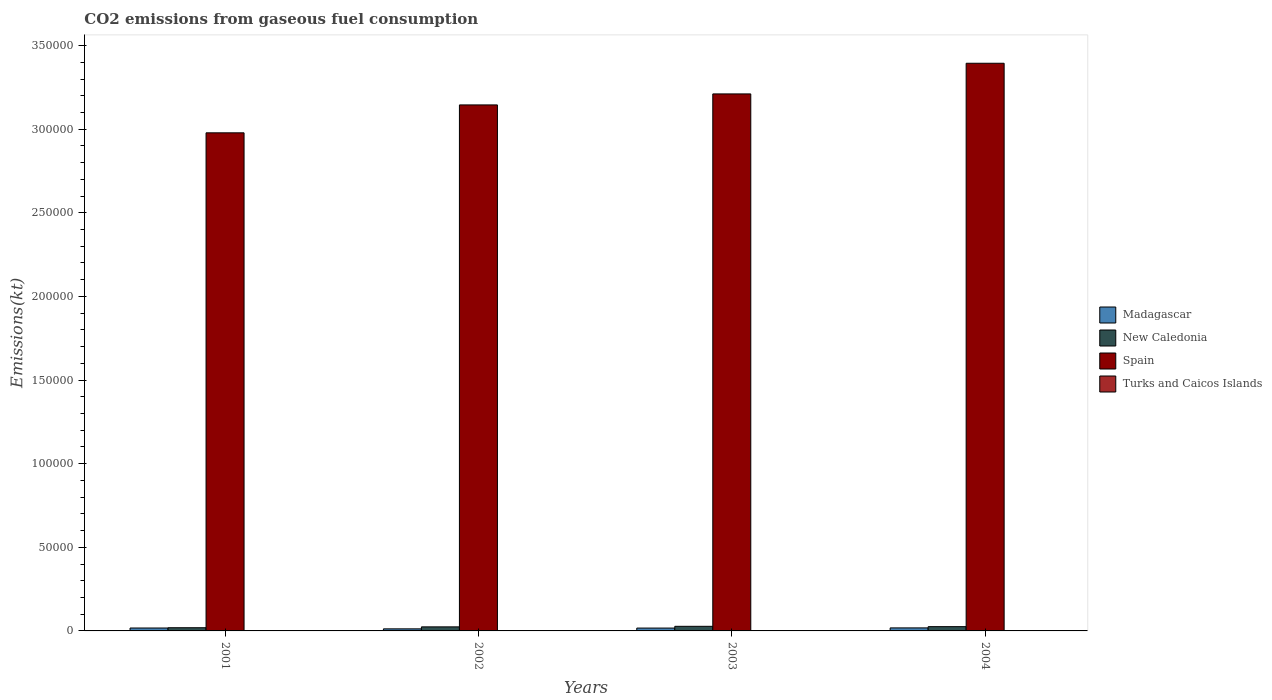How many different coloured bars are there?
Provide a succinct answer. 4. How many groups of bars are there?
Make the answer very short. 4. Are the number of bars per tick equal to the number of legend labels?
Give a very brief answer. Yes. How many bars are there on the 4th tick from the left?
Give a very brief answer. 4. In how many cases, is the number of bars for a given year not equal to the number of legend labels?
Your answer should be very brief. 0. What is the amount of CO2 emitted in Turks and Caicos Islands in 2004?
Your response must be concise. 102.68. Across all years, what is the maximum amount of CO2 emitted in Madagascar?
Offer a very short reply. 1807.83. Across all years, what is the minimum amount of CO2 emitted in Madagascar?
Give a very brief answer. 1235.78. In which year was the amount of CO2 emitted in New Caledonia maximum?
Make the answer very short. 2003. What is the total amount of CO2 emitted in Spain in the graph?
Give a very brief answer. 1.27e+06. What is the difference between the amount of CO2 emitted in Turks and Caicos Islands in 2001 and that in 2004?
Ensure brevity in your answer.  -88.01. What is the difference between the amount of CO2 emitted in New Caledonia in 2001 and the amount of CO2 emitted in Madagascar in 2004?
Keep it short and to the point. 99.01. What is the average amount of CO2 emitted in New Caledonia per year?
Make the answer very short. 2409.22. In the year 2003, what is the difference between the amount of CO2 emitted in New Caledonia and amount of CO2 emitted in Turks and Caicos Islands?
Offer a very short reply. 2647.57. What is the ratio of the amount of CO2 emitted in Madagascar in 2001 to that in 2003?
Keep it short and to the point. 1.02. What is the difference between the highest and the second highest amount of CO2 emitted in Madagascar?
Offer a terse response. 66.01. What is the difference between the highest and the lowest amount of CO2 emitted in Spain?
Provide a succinct answer. 4.16e+04. Is it the case that in every year, the sum of the amount of CO2 emitted in Madagascar and amount of CO2 emitted in Turks and Caicos Islands is greater than the sum of amount of CO2 emitted in Spain and amount of CO2 emitted in New Caledonia?
Offer a terse response. Yes. What does the 4th bar from the left in 2002 represents?
Provide a short and direct response. Turks and Caicos Islands. What does the 2nd bar from the right in 2003 represents?
Provide a short and direct response. Spain. Is it the case that in every year, the sum of the amount of CO2 emitted in New Caledonia and amount of CO2 emitted in Madagascar is greater than the amount of CO2 emitted in Spain?
Offer a very short reply. No. How many years are there in the graph?
Offer a terse response. 4. Does the graph contain grids?
Provide a short and direct response. No. Where does the legend appear in the graph?
Your answer should be compact. Center right. How are the legend labels stacked?
Your response must be concise. Vertical. What is the title of the graph?
Provide a short and direct response. CO2 emissions from gaseous fuel consumption. What is the label or title of the Y-axis?
Offer a very short reply. Emissions(kt). What is the Emissions(kt) in Madagascar in 2001?
Your answer should be compact. 1741.83. What is the Emissions(kt) of New Caledonia in 2001?
Make the answer very short. 1906.84. What is the Emissions(kt) in Spain in 2001?
Ensure brevity in your answer.  2.98e+05. What is the Emissions(kt) of Turks and Caicos Islands in 2001?
Make the answer very short. 14.67. What is the Emissions(kt) in Madagascar in 2002?
Make the answer very short. 1235.78. What is the Emissions(kt) in New Caledonia in 2002?
Give a very brief answer. 2427.55. What is the Emissions(kt) of Spain in 2002?
Your answer should be compact. 3.15e+05. What is the Emissions(kt) in Turks and Caicos Islands in 2002?
Your answer should be compact. 99.01. What is the Emissions(kt) of Madagascar in 2003?
Offer a terse response. 1701.49. What is the Emissions(kt) of New Caledonia in 2003?
Your answer should be compact. 2750.25. What is the Emissions(kt) in Spain in 2003?
Your answer should be very brief. 3.21e+05. What is the Emissions(kt) of Turks and Caicos Islands in 2003?
Your response must be concise. 102.68. What is the Emissions(kt) in Madagascar in 2004?
Offer a very short reply. 1807.83. What is the Emissions(kt) in New Caledonia in 2004?
Offer a terse response. 2552.23. What is the Emissions(kt) of Spain in 2004?
Make the answer very short. 3.39e+05. What is the Emissions(kt) in Turks and Caicos Islands in 2004?
Ensure brevity in your answer.  102.68. Across all years, what is the maximum Emissions(kt) in Madagascar?
Make the answer very short. 1807.83. Across all years, what is the maximum Emissions(kt) in New Caledonia?
Ensure brevity in your answer.  2750.25. Across all years, what is the maximum Emissions(kt) in Spain?
Your answer should be very brief. 3.39e+05. Across all years, what is the maximum Emissions(kt) of Turks and Caicos Islands?
Offer a very short reply. 102.68. Across all years, what is the minimum Emissions(kt) of Madagascar?
Give a very brief answer. 1235.78. Across all years, what is the minimum Emissions(kt) of New Caledonia?
Keep it short and to the point. 1906.84. Across all years, what is the minimum Emissions(kt) in Spain?
Give a very brief answer. 2.98e+05. Across all years, what is the minimum Emissions(kt) in Turks and Caicos Islands?
Your response must be concise. 14.67. What is the total Emissions(kt) of Madagascar in the graph?
Ensure brevity in your answer.  6486.92. What is the total Emissions(kt) in New Caledonia in the graph?
Make the answer very short. 9636.88. What is the total Emissions(kt) in Spain in the graph?
Provide a succinct answer. 1.27e+06. What is the total Emissions(kt) in Turks and Caicos Islands in the graph?
Your answer should be compact. 319.03. What is the difference between the Emissions(kt) in Madagascar in 2001 and that in 2002?
Provide a succinct answer. 506.05. What is the difference between the Emissions(kt) in New Caledonia in 2001 and that in 2002?
Offer a very short reply. -520.71. What is the difference between the Emissions(kt) in Spain in 2001 and that in 2002?
Keep it short and to the point. -1.67e+04. What is the difference between the Emissions(kt) in Turks and Caicos Islands in 2001 and that in 2002?
Give a very brief answer. -84.34. What is the difference between the Emissions(kt) in Madagascar in 2001 and that in 2003?
Give a very brief answer. 40.34. What is the difference between the Emissions(kt) in New Caledonia in 2001 and that in 2003?
Your answer should be compact. -843.41. What is the difference between the Emissions(kt) of Spain in 2001 and that in 2003?
Provide a short and direct response. -2.33e+04. What is the difference between the Emissions(kt) in Turks and Caicos Islands in 2001 and that in 2003?
Give a very brief answer. -88.01. What is the difference between the Emissions(kt) in Madagascar in 2001 and that in 2004?
Ensure brevity in your answer.  -66.01. What is the difference between the Emissions(kt) of New Caledonia in 2001 and that in 2004?
Provide a short and direct response. -645.39. What is the difference between the Emissions(kt) of Spain in 2001 and that in 2004?
Your answer should be very brief. -4.16e+04. What is the difference between the Emissions(kt) of Turks and Caicos Islands in 2001 and that in 2004?
Your answer should be very brief. -88.01. What is the difference between the Emissions(kt) in Madagascar in 2002 and that in 2003?
Offer a very short reply. -465.71. What is the difference between the Emissions(kt) in New Caledonia in 2002 and that in 2003?
Your answer should be compact. -322.7. What is the difference between the Emissions(kt) in Spain in 2002 and that in 2003?
Your answer should be compact. -6578.6. What is the difference between the Emissions(kt) of Turks and Caicos Islands in 2002 and that in 2003?
Your response must be concise. -3.67. What is the difference between the Emissions(kt) in Madagascar in 2002 and that in 2004?
Ensure brevity in your answer.  -572.05. What is the difference between the Emissions(kt) in New Caledonia in 2002 and that in 2004?
Give a very brief answer. -124.68. What is the difference between the Emissions(kt) in Spain in 2002 and that in 2004?
Your response must be concise. -2.49e+04. What is the difference between the Emissions(kt) in Turks and Caicos Islands in 2002 and that in 2004?
Keep it short and to the point. -3.67. What is the difference between the Emissions(kt) of Madagascar in 2003 and that in 2004?
Give a very brief answer. -106.34. What is the difference between the Emissions(kt) of New Caledonia in 2003 and that in 2004?
Your response must be concise. 198.02. What is the difference between the Emissions(kt) in Spain in 2003 and that in 2004?
Provide a short and direct response. -1.83e+04. What is the difference between the Emissions(kt) in Madagascar in 2001 and the Emissions(kt) in New Caledonia in 2002?
Ensure brevity in your answer.  -685.73. What is the difference between the Emissions(kt) in Madagascar in 2001 and the Emissions(kt) in Spain in 2002?
Ensure brevity in your answer.  -3.13e+05. What is the difference between the Emissions(kt) in Madagascar in 2001 and the Emissions(kt) in Turks and Caicos Islands in 2002?
Give a very brief answer. 1642.82. What is the difference between the Emissions(kt) of New Caledonia in 2001 and the Emissions(kt) of Spain in 2002?
Your answer should be very brief. -3.13e+05. What is the difference between the Emissions(kt) of New Caledonia in 2001 and the Emissions(kt) of Turks and Caicos Islands in 2002?
Your response must be concise. 1807.83. What is the difference between the Emissions(kt) in Spain in 2001 and the Emissions(kt) in Turks and Caicos Islands in 2002?
Provide a succinct answer. 2.98e+05. What is the difference between the Emissions(kt) in Madagascar in 2001 and the Emissions(kt) in New Caledonia in 2003?
Give a very brief answer. -1008.42. What is the difference between the Emissions(kt) of Madagascar in 2001 and the Emissions(kt) of Spain in 2003?
Offer a terse response. -3.19e+05. What is the difference between the Emissions(kt) in Madagascar in 2001 and the Emissions(kt) in Turks and Caicos Islands in 2003?
Your response must be concise. 1639.15. What is the difference between the Emissions(kt) in New Caledonia in 2001 and the Emissions(kt) in Spain in 2003?
Offer a terse response. -3.19e+05. What is the difference between the Emissions(kt) in New Caledonia in 2001 and the Emissions(kt) in Turks and Caicos Islands in 2003?
Give a very brief answer. 1804.16. What is the difference between the Emissions(kt) of Spain in 2001 and the Emissions(kt) of Turks and Caicos Islands in 2003?
Your response must be concise. 2.98e+05. What is the difference between the Emissions(kt) in Madagascar in 2001 and the Emissions(kt) in New Caledonia in 2004?
Your response must be concise. -810.41. What is the difference between the Emissions(kt) in Madagascar in 2001 and the Emissions(kt) in Spain in 2004?
Offer a terse response. -3.38e+05. What is the difference between the Emissions(kt) in Madagascar in 2001 and the Emissions(kt) in Turks and Caicos Islands in 2004?
Make the answer very short. 1639.15. What is the difference between the Emissions(kt) in New Caledonia in 2001 and the Emissions(kt) in Spain in 2004?
Ensure brevity in your answer.  -3.38e+05. What is the difference between the Emissions(kt) of New Caledonia in 2001 and the Emissions(kt) of Turks and Caicos Islands in 2004?
Provide a succinct answer. 1804.16. What is the difference between the Emissions(kt) in Spain in 2001 and the Emissions(kt) in Turks and Caicos Islands in 2004?
Provide a short and direct response. 2.98e+05. What is the difference between the Emissions(kt) in Madagascar in 2002 and the Emissions(kt) in New Caledonia in 2003?
Provide a short and direct response. -1514.47. What is the difference between the Emissions(kt) in Madagascar in 2002 and the Emissions(kt) in Spain in 2003?
Offer a terse response. -3.20e+05. What is the difference between the Emissions(kt) in Madagascar in 2002 and the Emissions(kt) in Turks and Caicos Islands in 2003?
Provide a succinct answer. 1133.1. What is the difference between the Emissions(kt) of New Caledonia in 2002 and the Emissions(kt) of Spain in 2003?
Your response must be concise. -3.19e+05. What is the difference between the Emissions(kt) in New Caledonia in 2002 and the Emissions(kt) in Turks and Caicos Islands in 2003?
Give a very brief answer. 2324.88. What is the difference between the Emissions(kt) of Spain in 2002 and the Emissions(kt) of Turks and Caicos Islands in 2003?
Your response must be concise. 3.14e+05. What is the difference between the Emissions(kt) in Madagascar in 2002 and the Emissions(kt) in New Caledonia in 2004?
Provide a short and direct response. -1316.45. What is the difference between the Emissions(kt) in Madagascar in 2002 and the Emissions(kt) in Spain in 2004?
Your response must be concise. -3.38e+05. What is the difference between the Emissions(kt) in Madagascar in 2002 and the Emissions(kt) in Turks and Caicos Islands in 2004?
Give a very brief answer. 1133.1. What is the difference between the Emissions(kt) in New Caledonia in 2002 and the Emissions(kt) in Spain in 2004?
Offer a terse response. -3.37e+05. What is the difference between the Emissions(kt) in New Caledonia in 2002 and the Emissions(kt) in Turks and Caicos Islands in 2004?
Your answer should be very brief. 2324.88. What is the difference between the Emissions(kt) of Spain in 2002 and the Emissions(kt) of Turks and Caicos Islands in 2004?
Keep it short and to the point. 3.14e+05. What is the difference between the Emissions(kt) of Madagascar in 2003 and the Emissions(kt) of New Caledonia in 2004?
Ensure brevity in your answer.  -850.74. What is the difference between the Emissions(kt) in Madagascar in 2003 and the Emissions(kt) in Spain in 2004?
Your response must be concise. -3.38e+05. What is the difference between the Emissions(kt) in Madagascar in 2003 and the Emissions(kt) in Turks and Caicos Islands in 2004?
Provide a succinct answer. 1598.81. What is the difference between the Emissions(kt) in New Caledonia in 2003 and the Emissions(kt) in Spain in 2004?
Your response must be concise. -3.37e+05. What is the difference between the Emissions(kt) of New Caledonia in 2003 and the Emissions(kt) of Turks and Caicos Islands in 2004?
Ensure brevity in your answer.  2647.57. What is the difference between the Emissions(kt) of Spain in 2003 and the Emissions(kt) of Turks and Caicos Islands in 2004?
Provide a short and direct response. 3.21e+05. What is the average Emissions(kt) in Madagascar per year?
Ensure brevity in your answer.  1621.73. What is the average Emissions(kt) of New Caledonia per year?
Your answer should be compact. 2409.22. What is the average Emissions(kt) of Spain per year?
Your response must be concise. 3.18e+05. What is the average Emissions(kt) of Turks and Caicos Islands per year?
Your response must be concise. 79.76. In the year 2001, what is the difference between the Emissions(kt) in Madagascar and Emissions(kt) in New Caledonia?
Your answer should be compact. -165.01. In the year 2001, what is the difference between the Emissions(kt) in Madagascar and Emissions(kt) in Spain?
Provide a succinct answer. -2.96e+05. In the year 2001, what is the difference between the Emissions(kt) of Madagascar and Emissions(kt) of Turks and Caicos Islands?
Your answer should be compact. 1727.16. In the year 2001, what is the difference between the Emissions(kt) of New Caledonia and Emissions(kt) of Spain?
Your response must be concise. -2.96e+05. In the year 2001, what is the difference between the Emissions(kt) in New Caledonia and Emissions(kt) in Turks and Caicos Islands?
Offer a very short reply. 1892.17. In the year 2001, what is the difference between the Emissions(kt) of Spain and Emissions(kt) of Turks and Caicos Islands?
Provide a succinct answer. 2.98e+05. In the year 2002, what is the difference between the Emissions(kt) of Madagascar and Emissions(kt) of New Caledonia?
Your answer should be very brief. -1191.78. In the year 2002, what is the difference between the Emissions(kt) in Madagascar and Emissions(kt) in Spain?
Make the answer very short. -3.13e+05. In the year 2002, what is the difference between the Emissions(kt) in Madagascar and Emissions(kt) in Turks and Caicos Islands?
Offer a very short reply. 1136.77. In the year 2002, what is the difference between the Emissions(kt) in New Caledonia and Emissions(kt) in Spain?
Make the answer very short. -3.12e+05. In the year 2002, what is the difference between the Emissions(kt) in New Caledonia and Emissions(kt) in Turks and Caicos Islands?
Your answer should be very brief. 2328.55. In the year 2002, what is the difference between the Emissions(kt) in Spain and Emissions(kt) in Turks and Caicos Islands?
Give a very brief answer. 3.14e+05. In the year 2003, what is the difference between the Emissions(kt) in Madagascar and Emissions(kt) in New Caledonia?
Make the answer very short. -1048.76. In the year 2003, what is the difference between the Emissions(kt) in Madagascar and Emissions(kt) in Spain?
Offer a very short reply. -3.19e+05. In the year 2003, what is the difference between the Emissions(kt) in Madagascar and Emissions(kt) in Turks and Caicos Islands?
Your response must be concise. 1598.81. In the year 2003, what is the difference between the Emissions(kt) of New Caledonia and Emissions(kt) of Spain?
Offer a very short reply. -3.18e+05. In the year 2003, what is the difference between the Emissions(kt) of New Caledonia and Emissions(kt) of Turks and Caicos Islands?
Your answer should be very brief. 2647.57. In the year 2003, what is the difference between the Emissions(kt) in Spain and Emissions(kt) in Turks and Caicos Islands?
Provide a succinct answer. 3.21e+05. In the year 2004, what is the difference between the Emissions(kt) in Madagascar and Emissions(kt) in New Caledonia?
Keep it short and to the point. -744.4. In the year 2004, what is the difference between the Emissions(kt) of Madagascar and Emissions(kt) of Spain?
Make the answer very short. -3.38e+05. In the year 2004, what is the difference between the Emissions(kt) of Madagascar and Emissions(kt) of Turks and Caicos Islands?
Your response must be concise. 1705.15. In the year 2004, what is the difference between the Emissions(kt) in New Caledonia and Emissions(kt) in Spain?
Provide a succinct answer. -3.37e+05. In the year 2004, what is the difference between the Emissions(kt) of New Caledonia and Emissions(kt) of Turks and Caicos Islands?
Provide a short and direct response. 2449.56. In the year 2004, what is the difference between the Emissions(kt) of Spain and Emissions(kt) of Turks and Caicos Islands?
Ensure brevity in your answer.  3.39e+05. What is the ratio of the Emissions(kt) of Madagascar in 2001 to that in 2002?
Offer a very short reply. 1.41. What is the ratio of the Emissions(kt) of New Caledonia in 2001 to that in 2002?
Give a very brief answer. 0.79. What is the ratio of the Emissions(kt) of Spain in 2001 to that in 2002?
Ensure brevity in your answer.  0.95. What is the ratio of the Emissions(kt) in Turks and Caicos Islands in 2001 to that in 2002?
Give a very brief answer. 0.15. What is the ratio of the Emissions(kt) in Madagascar in 2001 to that in 2003?
Make the answer very short. 1.02. What is the ratio of the Emissions(kt) of New Caledonia in 2001 to that in 2003?
Ensure brevity in your answer.  0.69. What is the ratio of the Emissions(kt) of Spain in 2001 to that in 2003?
Keep it short and to the point. 0.93. What is the ratio of the Emissions(kt) of Turks and Caicos Islands in 2001 to that in 2003?
Keep it short and to the point. 0.14. What is the ratio of the Emissions(kt) in Madagascar in 2001 to that in 2004?
Offer a very short reply. 0.96. What is the ratio of the Emissions(kt) in New Caledonia in 2001 to that in 2004?
Keep it short and to the point. 0.75. What is the ratio of the Emissions(kt) of Spain in 2001 to that in 2004?
Offer a terse response. 0.88. What is the ratio of the Emissions(kt) of Turks and Caicos Islands in 2001 to that in 2004?
Your answer should be compact. 0.14. What is the ratio of the Emissions(kt) in Madagascar in 2002 to that in 2003?
Offer a terse response. 0.73. What is the ratio of the Emissions(kt) of New Caledonia in 2002 to that in 2003?
Ensure brevity in your answer.  0.88. What is the ratio of the Emissions(kt) in Spain in 2002 to that in 2003?
Offer a very short reply. 0.98. What is the ratio of the Emissions(kt) in Turks and Caicos Islands in 2002 to that in 2003?
Your answer should be very brief. 0.96. What is the ratio of the Emissions(kt) of Madagascar in 2002 to that in 2004?
Your answer should be compact. 0.68. What is the ratio of the Emissions(kt) in New Caledonia in 2002 to that in 2004?
Offer a very short reply. 0.95. What is the ratio of the Emissions(kt) of Spain in 2002 to that in 2004?
Your answer should be very brief. 0.93. What is the ratio of the Emissions(kt) of Turks and Caicos Islands in 2002 to that in 2004?
Make the answer very short. 0.96. What is the ratio of the Emissions(kt) in Madagascar in 2003 to that in 2004?
Offer a terse response. 0.94. What is the ratio of the Emissions(kt) of New Caledonia in 2003 to that in 2004?
Your response must be concise. 1.08. What is the ratio of the Emissions(kt) of Spain in 2003 to that in 2004?
Your response must be concise. 0.95. What is the ratio of the Emissions(kt) of Turks and Caicos Islands in 2003 to that in 2004?
Your answer should be compact. 1. What is the difference between the highest and the second highest Emissions(kt) in Madagascar?
Provide a short and direct response. 66.01. What is the difference between the highest and the second highest Emissions(kt) of New Caledonia?
Your response must be concise. 198.02. What is the difference between the highest and the second highest Emissions(kt) of Spain?
Give a very brief answer. 1.83e+04. What is the difference between the highest and the lowest Emissions(kt) in Madagascar?
Your answer should be very brief. 572.05. What is the difference between the highest and the lowest Emissions(kt) of New Caledonia?
Your response must be concise. 843.41. What is the difference between the highest and the lowest Emissions(kt) of Spain?
Your response must be concise. 4.16e+04. What is the difference between the highest and the lowest Emissions(kt) in Turks and Caicos Islands?
Give a very brief answer. 88.01. 